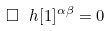Convert formula to latex. <formula><loc_0><loc_0><loc_500><loc_500>\Box \ h [ 1 ] ^ { \alpha \beta } = 0</formula> 